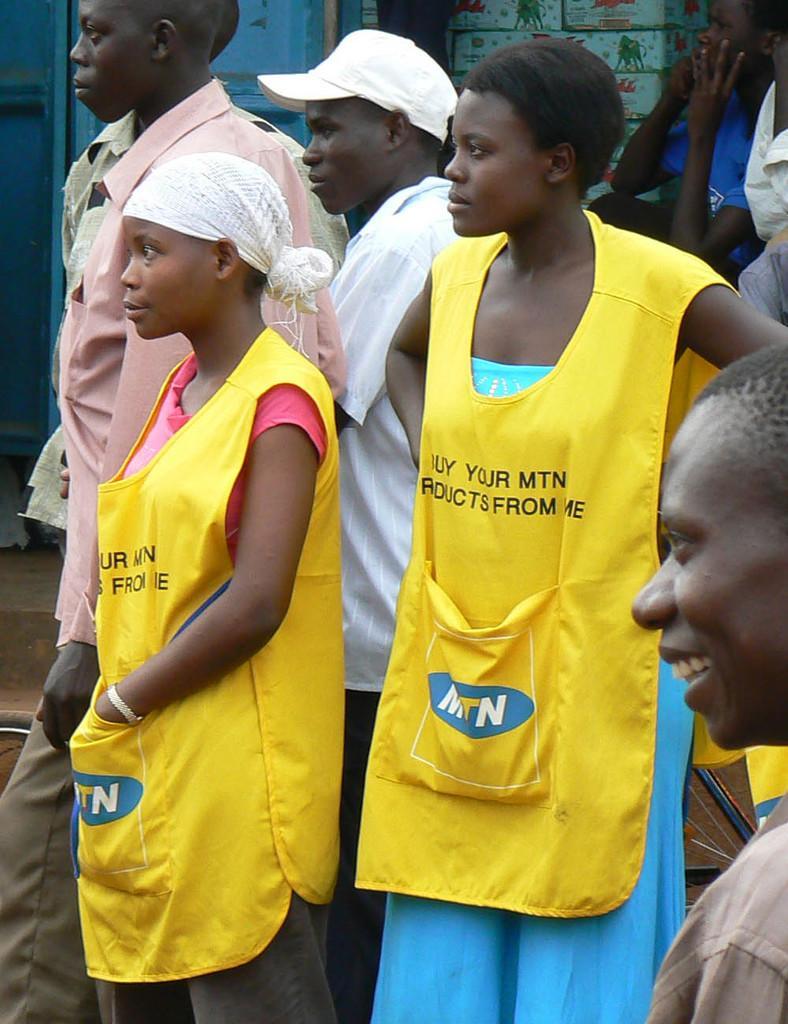Describe this image in one or two sentences. In this image we can see a group of people standing on the ground. One person is sitting. At the top of the image we can see some boxes with pictures and some text placed on the surface. 